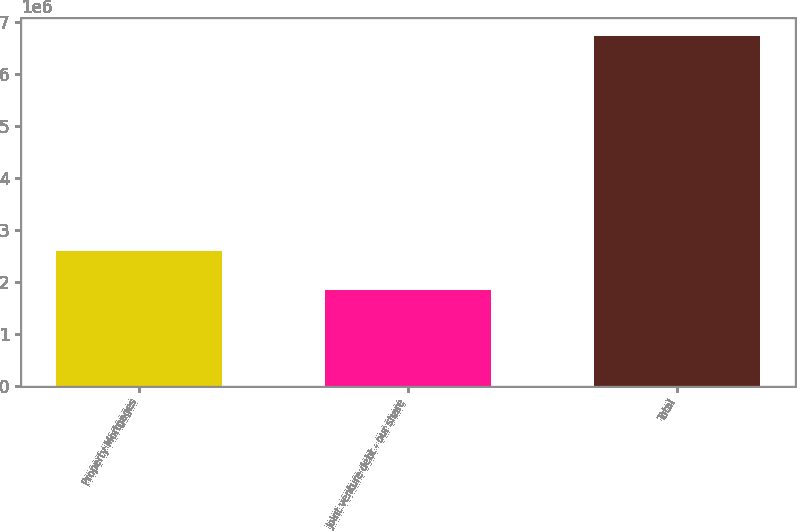Convert chart. <chart><loc_0><loc_0><loc_500><loc_500><bar_chart><fcel>Property Mortgages<fcel>Joint venture debt - our share<fcel>Total<nl><fcel>2.59555e+06<fcel>1.84872e+06<fcel>6.74141e+06<nl></chart> 